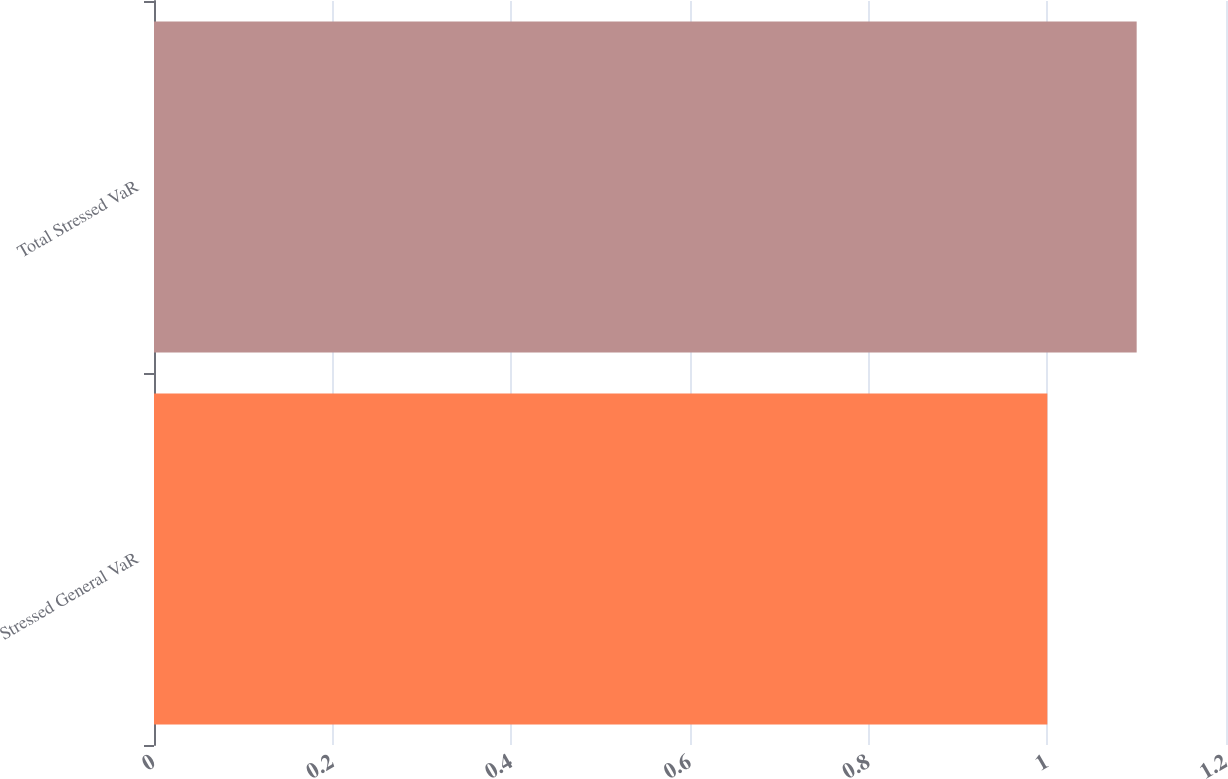Convert chart. <chart><loc_0><loc_0><loc_500><loc_500><bar_chart><fcel>Stressed General VaR<fcel>Total Stressed VaR<nl><fcel>1<fcel>1.1<nl></chart> 